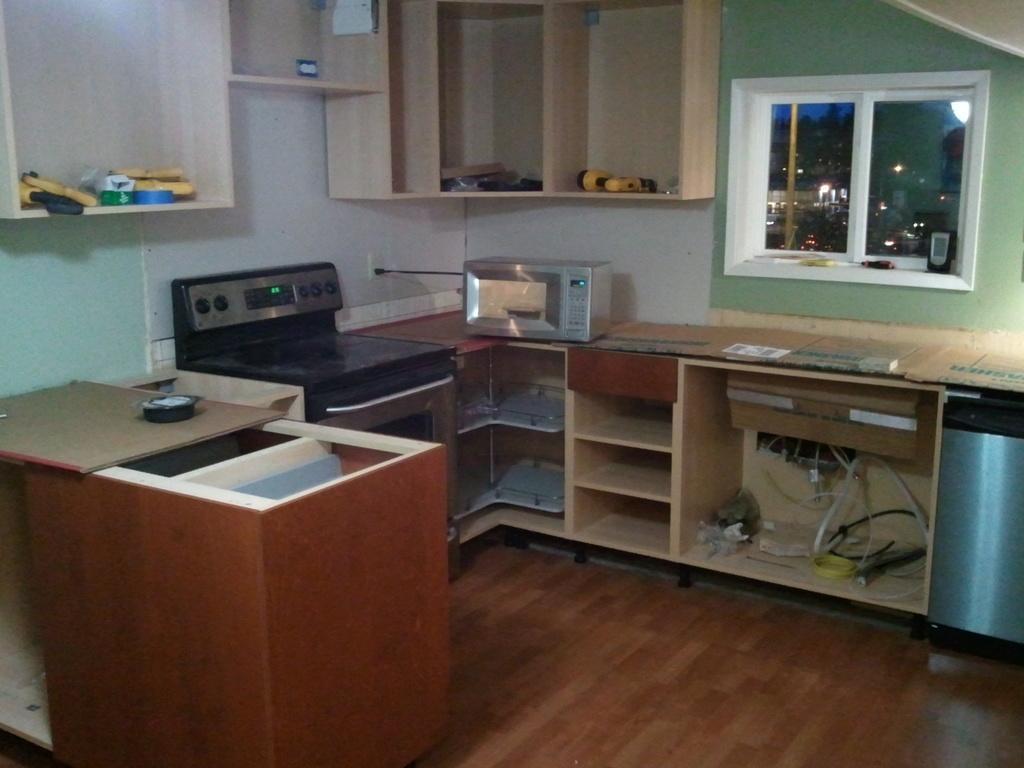Please provide a concise description of this image. In the image we can see there is an area of a room where there is a gas stove and an oven on the table and there is a window in between. 